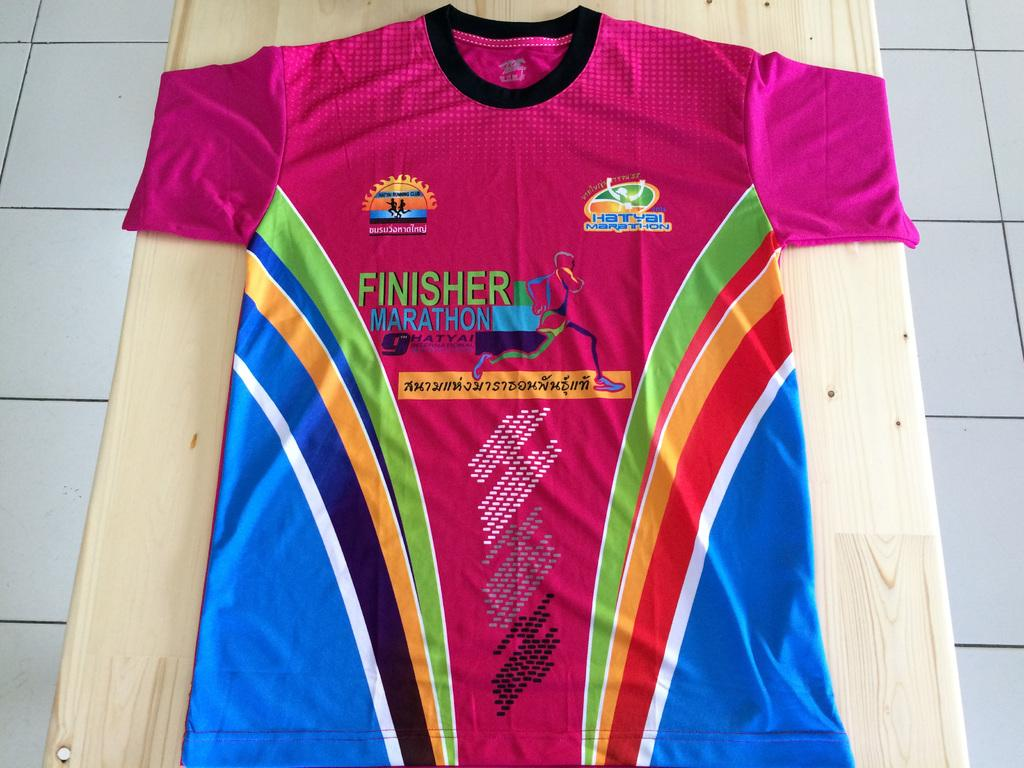<image>
Relay a brief, clear account of the picture shown. A colorful sports shirt has FINISHER MARATHON on it. 